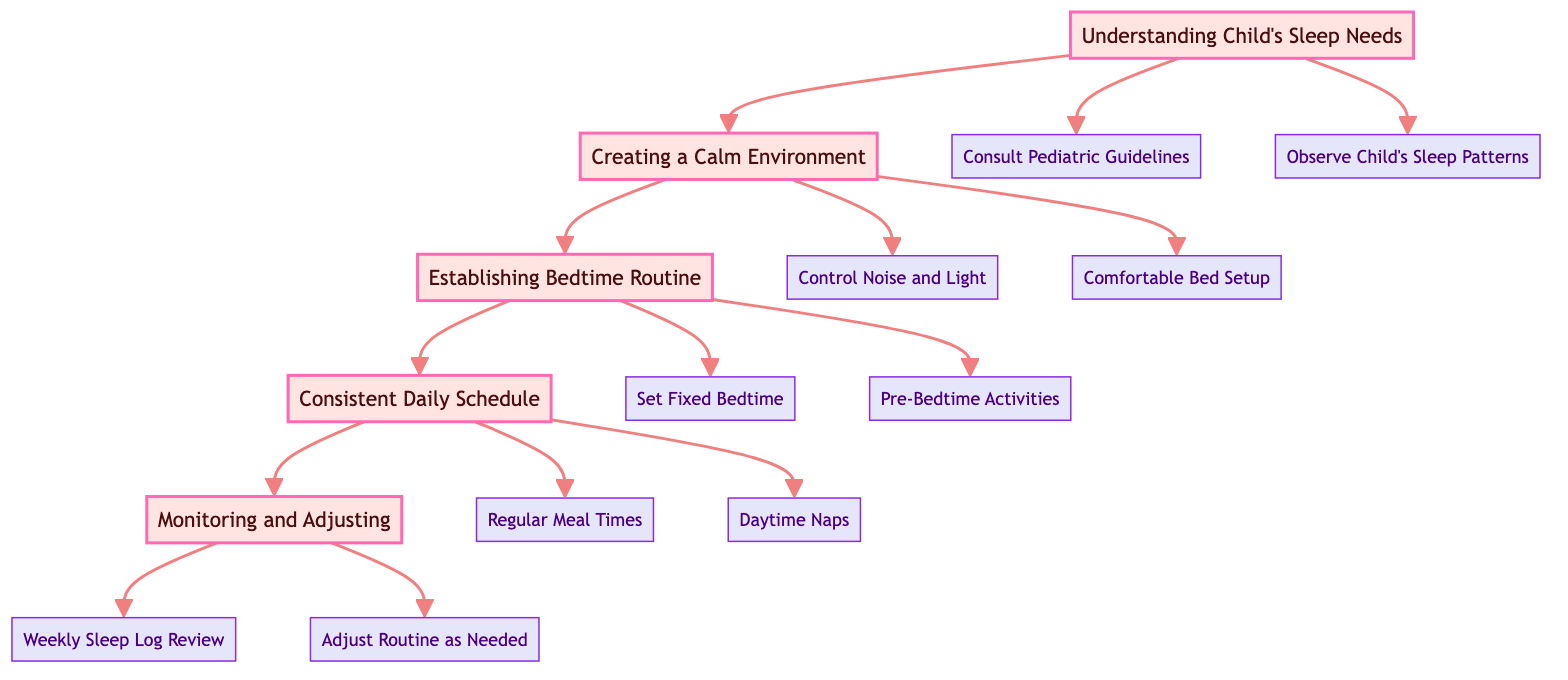What is the first step in the sleep routine development process? The diagram starts with "Understanding Child's Sleep Needs," indicating that this is the first step in the process.
Answer: Understanding Child's Sleep Needs How many actions are listed under "Creating a Calm Environment"? In the diagram, "Creating a Calm Environment" is connected to two actions: "Control Noise and Light" and "Comfortable Bed Setup." Thus, there are two actions listed.
Answer: 2 Which step follows "Establishing Bedtime Routine"? Flowing through the diagram, after "Establishing Bedtime Routine," the next step shown is "Consistent Daily Schedule."
Answer: Consistent Daily Schedule What action relates to regulating sleep patterns? The action "Regular Meal Times," found under "Consistent Daily Schedule," is specifically aimed at helping to regulate sleep patterns.
Answer: Regular Meal Times How many total steps are there in the diagram? The diagram contains five steps total: "Understanding Child's Sleep Needs," "Creating a Calm Environment," "Establishing Bedtime Routine," "Consistent Daily Schedule," and "Monitoring and Adjusting."
Answer: 5 What is the last step in the diagram? Tracing from the last node in the chart, the final step depicted is "Monitoring and Adjusting," concluding the pathway.
Answer: Monitoring and Adjusting Which two actions are linked to "Establishing Bedtime Routine"? The two actions linked to "Establishing Bedtime Routine" are "Set Fixed Bedtime" and "Pre-Bedtime Activities," which both aim to create a consistent routine.
Answer: Set Fixed Bedtime, Pre-Bedtime Activities What should you do if the sleep routine needs modification? According to the diagram, the appropriate action to take if adjustments are needed is "Adjust Routine as Needed," indicating a proactive approach to managing the sleep schedule.
Answer: Adjust Routine as Needed What is the connection between "Monitoring and Adjusting" and "Weekly Sleep Log Review"? "Weekly Sleep Log Review" is directly connected as an action under "Monitoring and Adjusting," meaning it is a necessary part of the routine to ensure sleep patterns are evaluated and refined.
Answer: Weekly Sleep Log Review 